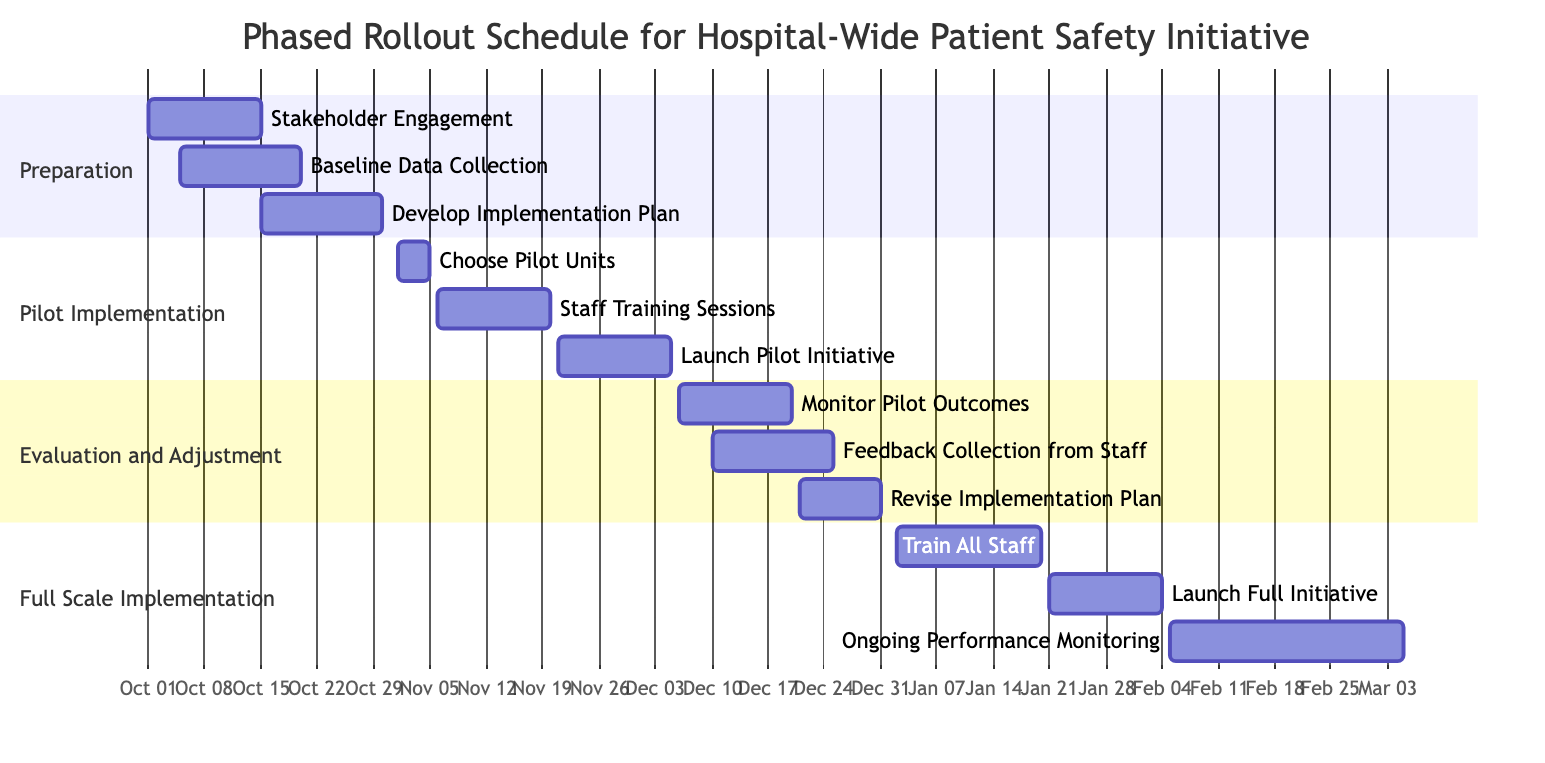what is the duration of the 'Stakeholder Engagement' task? The task 'Stakeholder Engagement' starts on October 1, 2023, and ends on October 15, 2023. To find the duration, count the days from the start to the end date, which is 15 days.
Answer: 15 days how many tasks are there in the 'Pilot Implementation' phase? In the 'Pilot Implementation' phase, there are three tasks listed: 'Choose Pilot Units', 'Staff Training Sessions', and 'Launch Pilot Initiative'. Therefore, the total number of tasks in this phase is three.
Answer: 3 what task follows 'Baseline Data Collection'? The 'Baseline Data Collection' task ends on October 20, 2023. The next task that starts after this task is 'Develop Implementation Plan', beginning on October 15, which overlaps partially. However, it is the next logically sequential task in this phase's preparation.
Answer: Develop Implementation Plan which task ends last in the 'Evaluation and Adjustment' phase? The 'Evaluation and Adjustment' phase includes three tasks. Among them, 'Revise Implementation Plan' has the latest end date of December 31, 2023. Thus, this task ends last within this phase.
Answer: Revise Implementation Plan what is the total duration of the 'Full Scale Implementation' phase? The 'Full Scale Implementation' phase starts on January 2, 2024, and ends on March 5, 2024. To calculate the duration, count the days for these dates, which results in a total of 63 days for this phase.
Answer: 63 days what is the start date of the 'Launch Pilot Initiative' task? The 'Launch Pilot Initiative' is a task within the 'Pilot Implementation' phase, and its start date is listed as November 21, 2023.
Answer: November 21, 2023 how many tasks are scheduled to run concurrently from December 10 to December 20? During the period from December 10 to December 20, two tasks are running concurrently: 'Monitor Pilot Outcomes' (December 6-20) and 'Feedback Collection from Staff' (December 10-25). Therefore, there are two tasks running concurrently within this timeframe.
Answer: 2 what is the last task in the Gantt chart? The last task in the Gantt chart is 'Ongoing Performance Monitoring', which starts on February 5, 2024, and ends on March 5, 2024.
Answer: Ongoing Performance Monitoring 